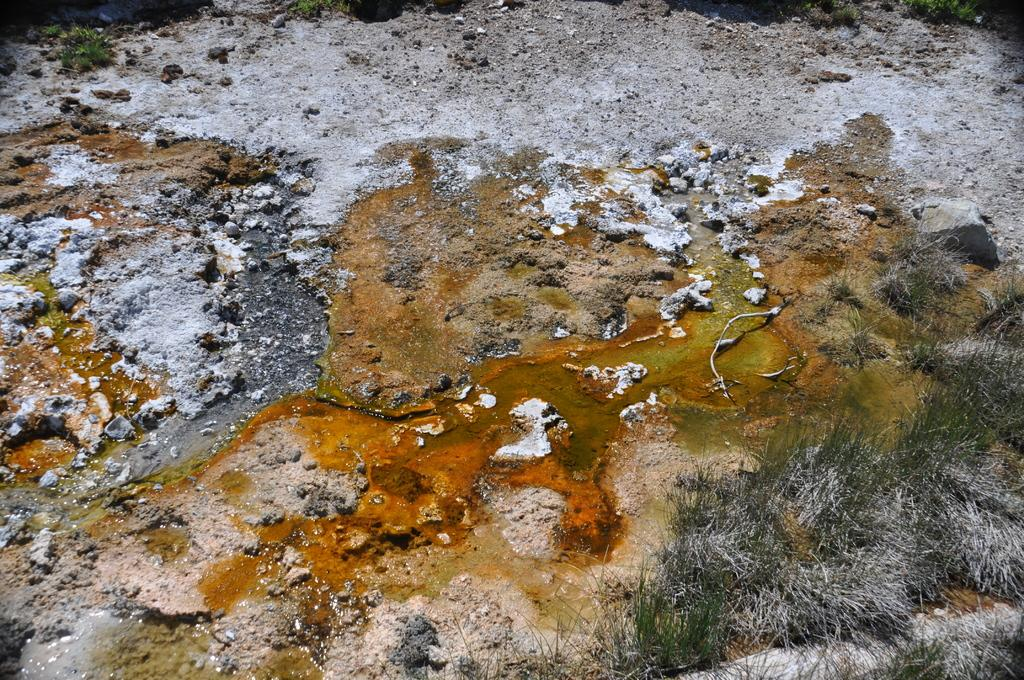What type of natural elements can be seen in the image? There are stones and grass in the image. What is covering the ground in the image? There is algae on the ground in the image. Can you see a toothbrush being used to clean the stones in the image? There is no toothbrush present in the image, and no cleaning activity is depicted. 